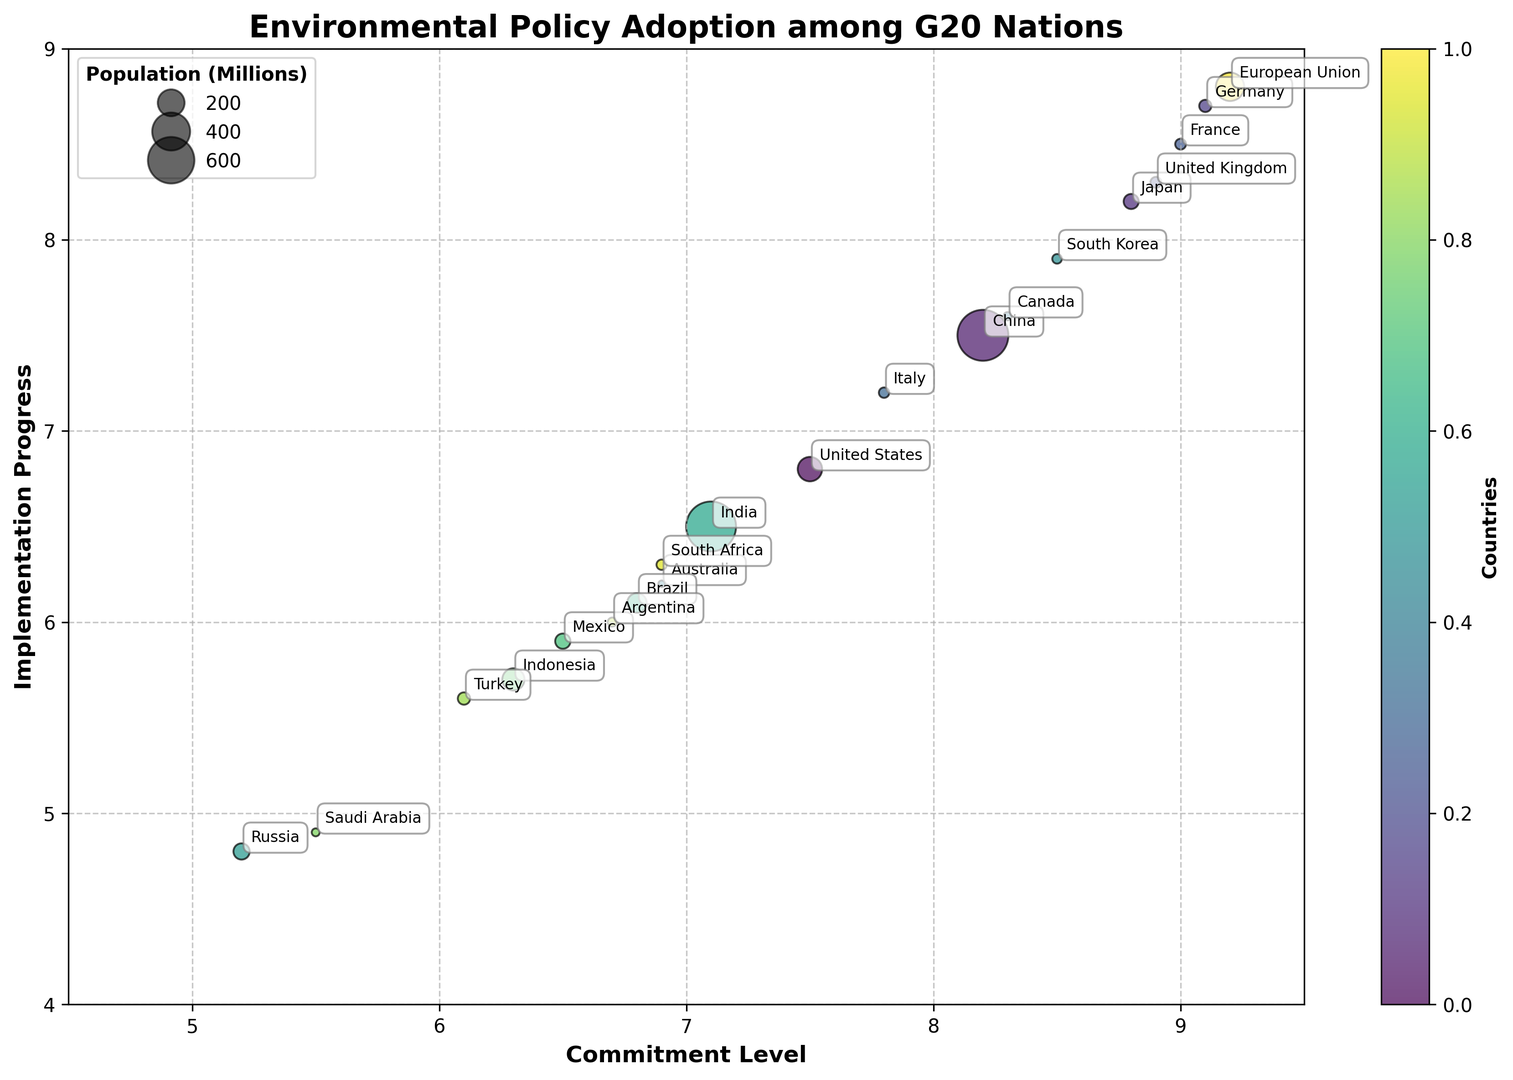Which country has the highest implementation progress? The figure shows the implementation progress on the y-axis. By finding the bubble with the highest position on the y-axis, we can see that the European Union has the highest implementation progress.
Answer: European Union Which countries have a commitment level above 8.5? The figure shows the commitment levels on the x-axis. The countries with bubbles positioned right above the 8.5 mark are Germany, United Kingdom, France, and Japan.
Answer: Germany, United Kingdom, France, Japan Which country has the largest population among the ones with a commitment level under 7.0? First, identify the bubbles to the left of the 7.0 mark on the x-axis for commitment level. Then, assess their relative bubble sizes, which represent population. China, despite not being under 7.0 in commitment, is the largest, but the largest within the constraint is Russia.
Answer: Russia What is the average implementation progress of the countries with commitment levels between 6.0 and 8.0? First, identify the countries with commitment levels between 6.0 and 8.0. These are Australia, Russia, India, Brazil, Mexico, Indonesia, Saudi Arabia, Turkey, and Argentina. Their implementation progresses are 6.2, 4.8, 6.5, 6.1, 5.9, 5.7, 4.9, 5.6, and 6.0 respectively. Calculate the average: (6.2 + 4.8 + 6.5 + 6.1 + 5.9 + 5.7 + 4.9 + 5.6 + 6.0) / 9 ≈ 5.74.
Answer: 5.74 Which two countries have the smallest gap between commitment level and implementation progress? Calculate the difference between commitment level and implementation progress for each country. The smallest gaps are observed in Germany (9.1-8.7 = 0.4) and the European Union (9.2-8.8 = 0.4).
Answer: Germany, European Union What is the total population of countries with a commitment level above 8? Identify countries with a commitment level above 8: China, Japan, Germany, United Kingdom, France, Canada, South Korea, and the European Union. Sum their populations: 1439 + 126 + 83 + 67 + 65 + 38 + 51 + 446 = 2315 million.
Answer: 2315 million Which country has the lowest implementation progress? The figure shows implementation progress on the y-axis. By finding the bubble with the lowest position on the y-axis, we can see that Russia has the lowest implementation progress.
Answer: Russia Which countries have both a commitment level and implementation progress above 8.0? On the x-axis, identify countries with a commitment level above 8.0 and then check their y-axis positions for implementation progress above 8.0. These countries are Germany, United Kingdom, France, Japan, and the European Union.
Answer: Germany, United Kingdom, France, Japan, European Union How does the implementation progress of Brazil compare to that of Argentina? Find Brazil and Argentina on the plot. Compare their positions on the y-axis to see that Argentina's implementation progress is slightly higher than Brazil's (6.0 vs. 6.1).
Answer: Argentina's is higher 